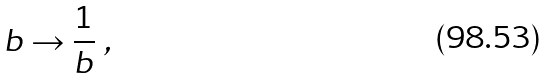<formula> <loc_0><loc_0><loc_500><loc_500>b \to { \frac { 1 } { b } } \ ,</formula> 